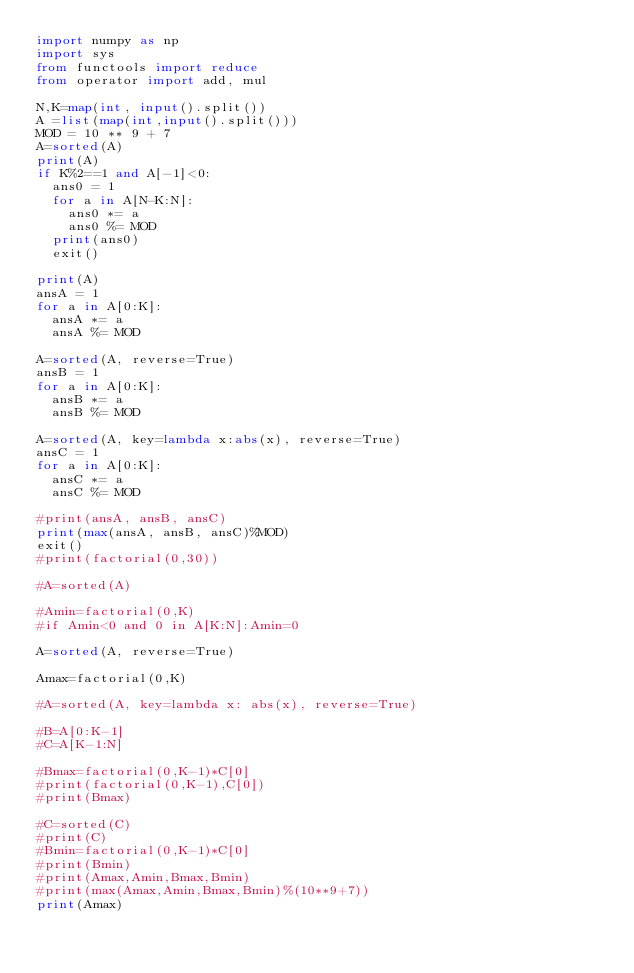<code> <loc_0><loc_0><loc_500><loc_500><_Python_>import numpy as np
import sys
from functools import reduce
from operator import add, mul
 
N,K=map(int, input().split())
A =list(map(int,input().split()))
MOD = 10 ** 9 + 7
A=sorted(A)
print(A)
if K%2==1 and A[-1]<0:
  ans0 = 1
  for a in A[N-K:N]:
    ans0 *= a
    ans0 %= MOD
  print(ans0)
  exit()

print(A)
ansA = 1
for a in A[0:K]:
  ansA *= a
  ansA %= MOD

A=sorted(A, reverse=True)
ansB = 1
for a in A[0:K]:
  ansB *= a
  ansB %= MOD

A=sorted(A, key=lambda x:abs(x), reverse=True)
ansC = 1
for a in A[0:K]:
  ansC *= a
  ansC %= MOD

#print(ansA, ansB, ansC)
print(max(ansA, ansB, ansC)%MOD)
exit()
#print(factorial(0,30))
      
#A=sorted(A)
 
#Amin=factorial(0,K)
#if Amin<0 and 0 in A[K:N]:Amin=0

A=sorted(A, reverse=True)
 
Amax=factorial(0,K)
 
#A=sorted(A, key=lambda x: abs(x), reverse=True)
 
#B=A[0:K-1]
#C=A[K-1:N]
 
#Bmax=factorial(0,K-1)*C[0]
#print(factorial(0,K-1),C[0])
#print(Bmax)
 
#C=sorted(C)
#print(C)
#Bmin=factorial(0,K-1)*C[0]
#print(Bmin)
#print(Amax,Amin,Bmax,Bmin)
#print(max(Amax,Amin,Bmax,Bmin)%(10**9+7))
print(Amax)</code> 